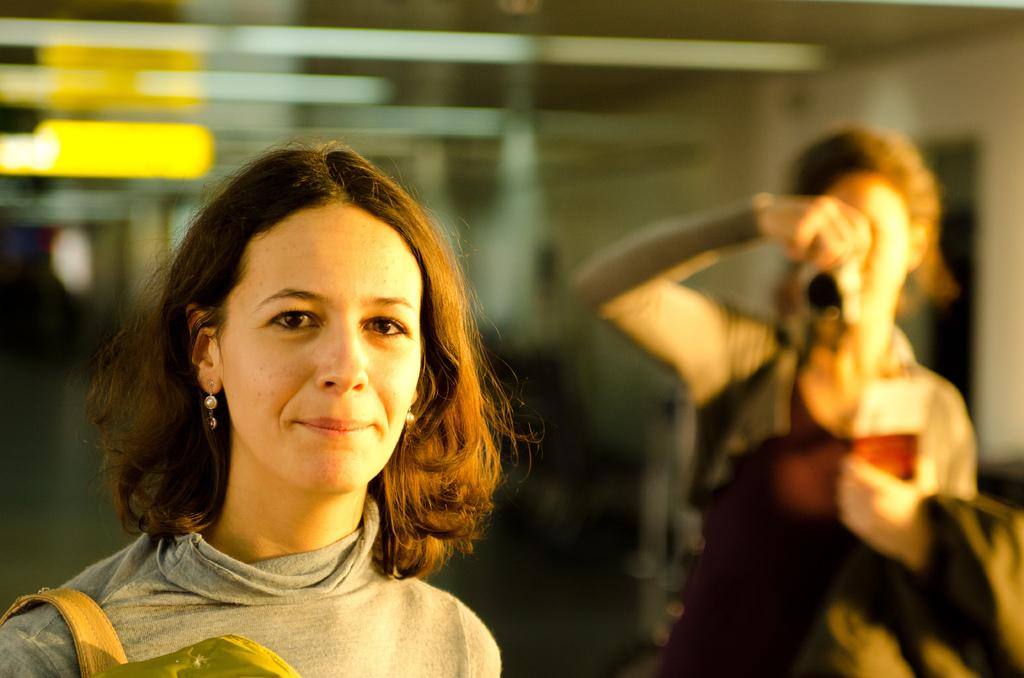How many women are in the image? There are two women in the image. What are the women doing in the image? The women are standing and holding objects. Can you describe the background of the image? The background of the image is blurred. What is one of the women doing on the right side of the image? On the right side of the image, one woman is taking a photo with a camera. How does the woman on the left side of the image help with the hot knowledge in the image? There is no mention of hot knowledge or the woman on the left side of the image helping with it, as the image only shows two women standing and holding objects. 